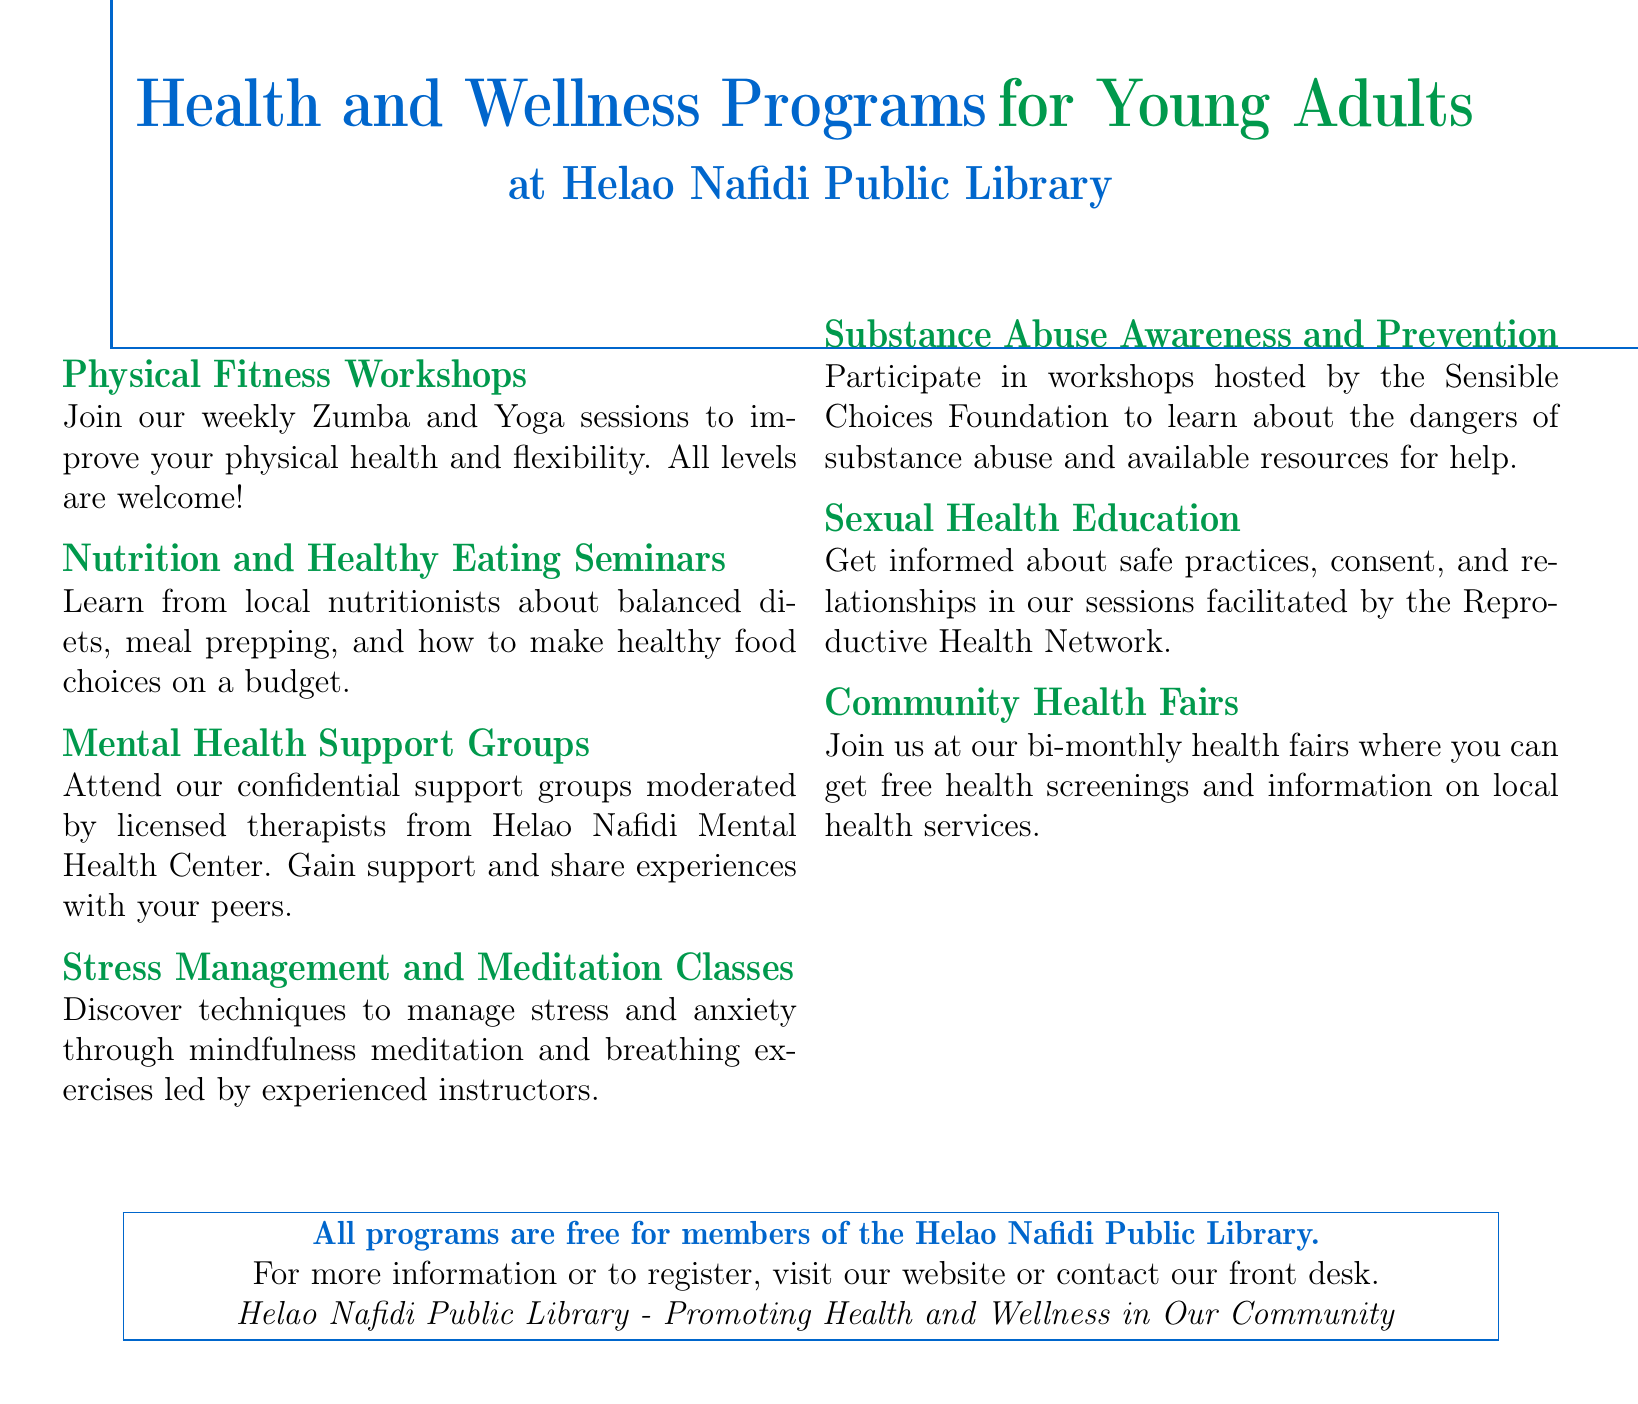what programs are offered for physical fitness? The document lists Zumba and Yoga sessions as physical fitness programs.
Answer: Zumba and Yoga who moderates the Mental Health Support Groups? The document specifies that licensed therapists from Helao Nafidi Mental Health Center moderate the groups.
Answer: licensed therapists how often do Community Health Fairs take place? The document states that the health fairs occur bi-monthly.
Answer: bi-monthly what organization hosts the Substance Abuse Awareness workshops? The document mentions that the workshops are hosted by the Sensible Choices Foundation.
Answer: Sensible Choices Foundation are all programs free for library members? The document confirms that all programs are free for members of the Helao Nafidi Public Library.
Answer: free what are the types of classes you can attend for stress management? The document indicates that mindfulness meditation and breathing exercises are taught in these classes.
Answer: mindfulness meditation and breathing exercises 